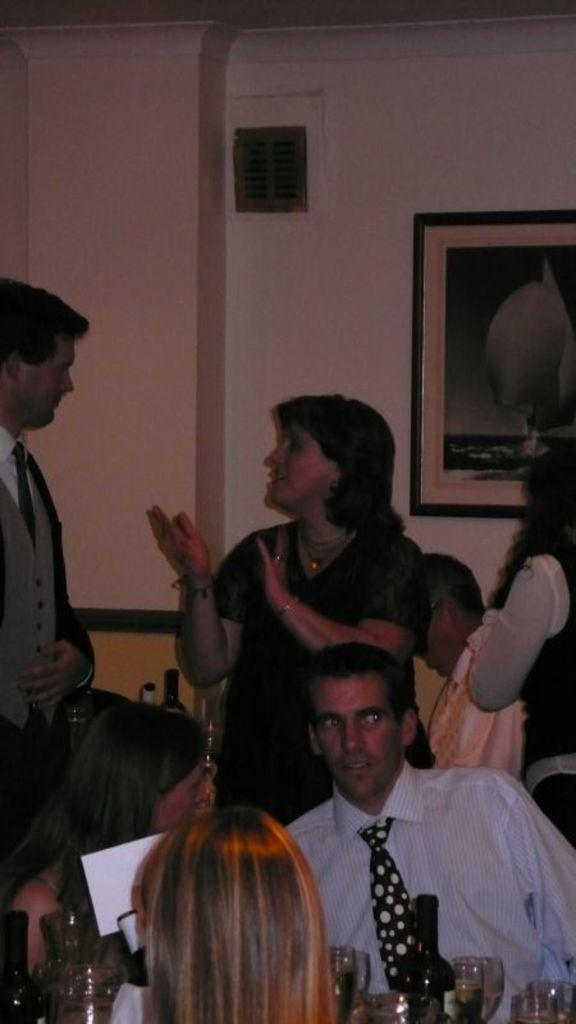What is the main subject of the image? The main subject of the image is a group of people. What can be seen in the background of the image? There is a photo frame and a wall in the background of the image. What type of toothpaste is being used by the people in the image? There is no toothpaste present in the image, as it features a group of people and a background with a photo frame and a wall. 